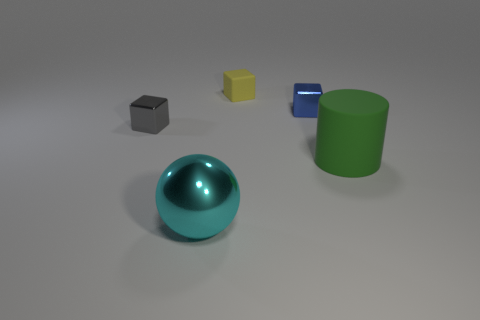There is another metallic object that is the same shape as the tiny gray metallic thing; what color is it? The other metallic object sharing the same cubic shape as the tiny gray one is blue in color, exhibiting a smooth and reflective surface that suggests a similarity in material composition as well. 